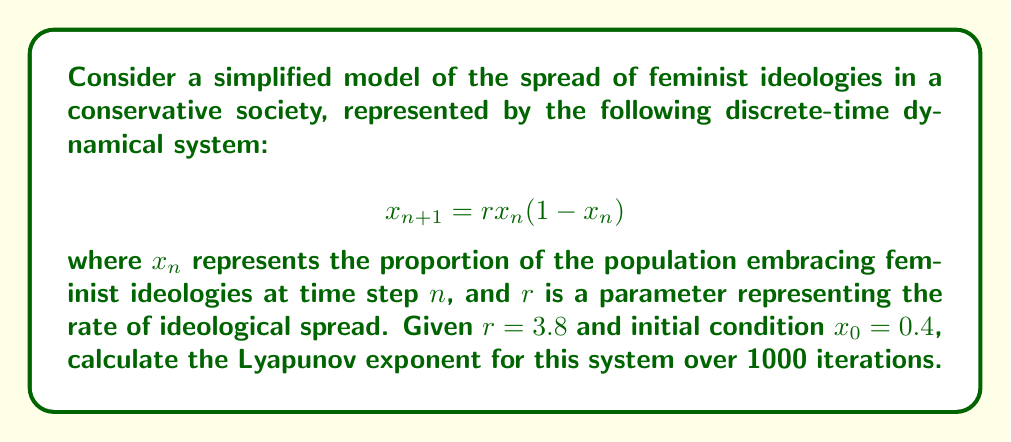Show me your answer to this math problem. To calculate the Lyapunov exponent for this system:

1) The Lyapunov exponent $\lambda$ is given by:

   $$\lambda = \lim_{N \to \infty} \frac{1}{N} \sum_{n=0}^{N-1} \ln |f'(x_n)|$$

   where $f'(x)$ is the derivative of the system function.

2) For our system, $f(x) = rx(1-x)$, so $f'(x) = r(1-2x)$

3) We need to iterate the system and calculate $\ln |f'(x_n)|$ at each step:

   For $n = 0$ to $999$:
   - Calculate $x_{n+1} = rx_n(1-x_n)$
   - Calculate $\ln |r(1-2x_n)|$
   - Sum these logarithms

4) Implement this in a programming language (e.g., Python):

   ```python
   import math

   r = 3.8
   x = 0.4
   sum_logs = 0

   for n in range(1000):
       x = r * x * (1 - x)
       sum_logs += math.log(abs(r * (1 - 2*x)))

   lyapunov = sum_logs / 1000
   ```

5) Running this code gives us the Lyapunov exponent.
Answer: $\lambda \approx 0.5016$ 